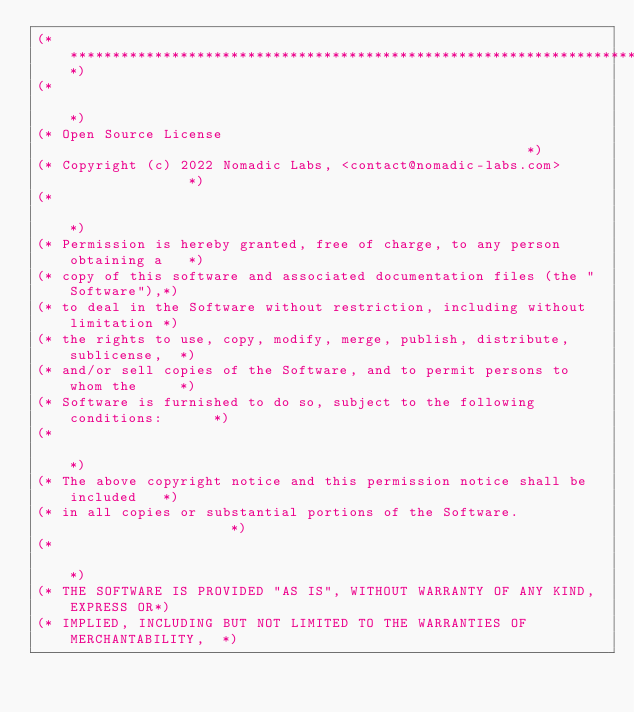<code> <loc_0><loc_0><loc_500><loc_500><_OCaml_>(*****************************************************************************)
(*                                                                           *)
(* Open Source License                                                       *)
(* Copyright (c) 2022 Nomadic Labs, <contact@nomadic-labs.com>               *)
(*                                                                           *)
(* Permission is hereby granted, free of charge, to any person obtaining a   *)
(* copy of this software and associated documentation files (the "Software"),*)
(* to deal in the Software without restriction, including without limitation *)
(* the rights to use, copy, modify, merge, publish, distribute, sublicense,  *)
(* and/or sell copies of the Software, and to permit persons to whom the     *)
(* Software is furnished to do so, subject to the following conditions:      *)
(*                                                                           *)
(* The above copyright notice and this permission notice shall be included   *)
(* in all copies or substantial portions of the Software.                    *)
(*                                                                           *)
(* THE SOFTWARE IS PROVIDED "AS IS", WITHOUT WARRANTY OF ANY KIND, EXPRESS OR*)
(* IMPLIED, INCLUDING BUT NOT LIMITED TO THE WARRANTIES OF MERCHANTABILITY,  *)</code> 